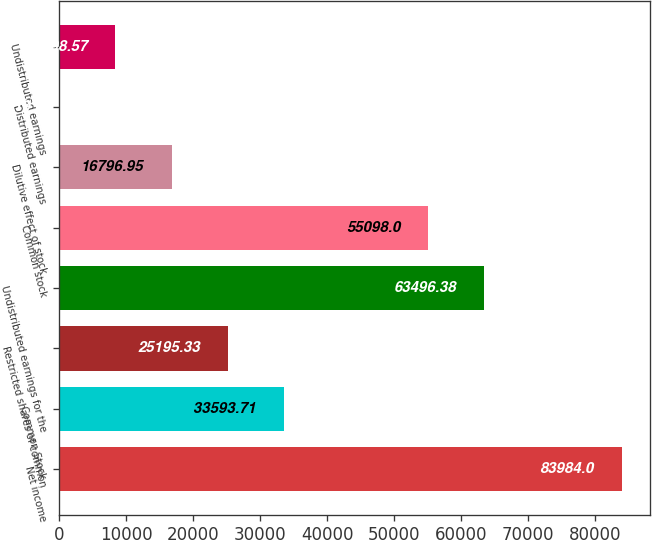<chart> <loc_0><loc_0><loc_500><loc_500><bar_chart><fcel>Net income<fcel>Common Stock<fcel>Restricted shares of common<fcel>Undistributed earnings for the<fcel>Common stock<fcel>Dilutive effect of stock<fcel>Distributed earnings<fcel>Undistributed earnings<nl><fcel>83984<fcel>33593.7<fcel>25195.3<fcel>63496.4<fcel>55098<fcel>16797<fcel>0.19<fcel>8398.57<nl></chart> 